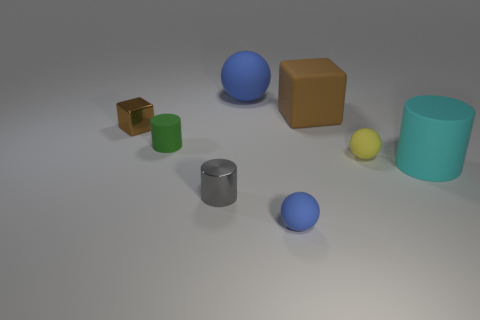Are there more small yellow matte objects than blue things?
Make the answer very short. No. What is the size of the ball that is both on the left side of the tiny yellow sphere and behind the cyan object?
Make the answer very short. Large. Are the blue ball that is behind the tiny blue matte object and the thing on the left side of the green thing made of the same material?
Offer a very short reply. No. There is a yellow matte thing that is the same size as the gray metallic cylinder; what is its shape?
Give a very brief answer. Sphere. Is the number of tiny blue objects less than the number of matte objects?
Your response must be concise. Yes. Is there a cylinder left of the large thing that is behind the large brown object?
Make the answer very short. Yes. Is there a brown metal cube that is behind the brown cube that is to the right of the blue matte sphere that is behind the rubber cube?
Your answer should be compact. No. There is a brown object on the right side of the gray object; is it the same shape as the metallic thing that is behind the gray metallic cylinder?
Provide a short and direct response. Yes. What color is the large sphere that is made of the same material as the small yellow thing?
Your answer should be compact. Blue. Are there fewer large cylinders that are in front of the cyan matte object than tiny gray rubber things?
Make the answer very short. No. 